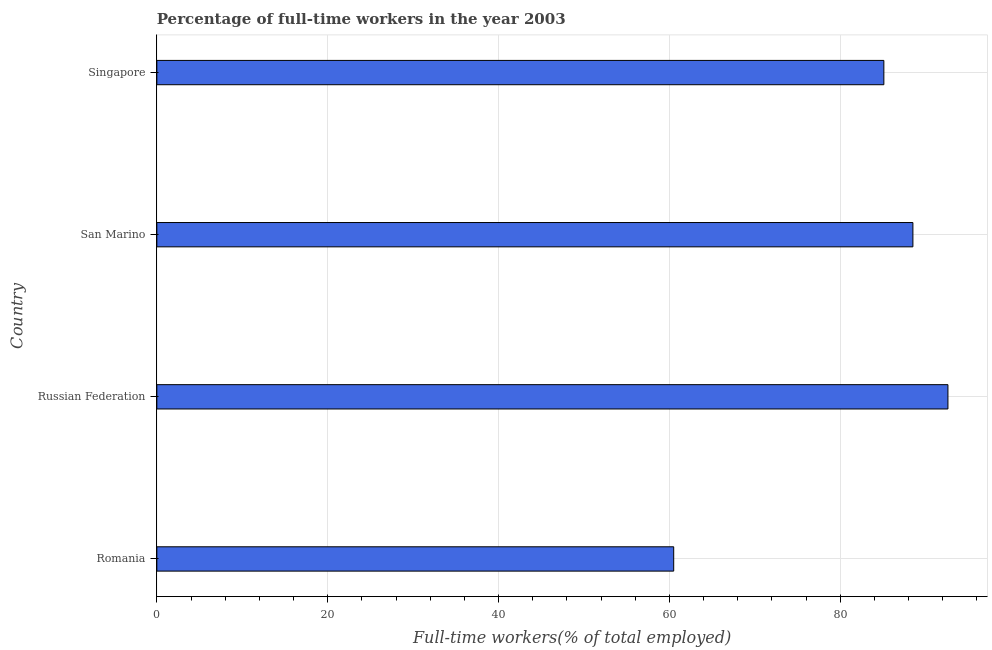Does the graph contain any zero values?
Ensure brevity in your answer.  No. What is the title of the graph?
Provide a short and direct response. Percentage of full-time workers in the year 2003. What is the label or title of the X-axis?
Your response must be concise. Full-time workers(% of total employed). What is the label or title of the Y-axis?
Offer a terse response. Country. What is the percentage of full-time workers in Singapore?
Provide a succinct answer. 85.1. Across all countries, what is the maximum percentage of full-time workers?
Keep it short and to the point. 92.6. Across all countries, what is the minimum percentage of full-time workers?
Give a very brief answer. 60.5. In which country was the percentage of full-time workers maximum?
Offer a very short reply. Russian Federation. In which country was the percentage of full-time workers minimum?
Provide a succinct answer. Romania. What is the sum of the percentage of full-time workers?
Keep it short and to the point. 326.7. What is the difference between the percentage of full-time workers in Romania and San Marino?
Provide a succinct answer. -28. What is the average percentage of full-time workers per country?
Keep it short and to the point. 81.67. What is the median percentage of full-time workers?
Provide a short and direct response. 86.8. In how many countries, is the percentage of full-time workers greater than 4 %?
Your answer should be compact. 4. What is the ratio of the percentage of full-time workers in Russian Federation to that in San Marino?
Provide a succinct answer. 1.05. Is the difference between the percentage of full-time workers in Russian Federation and San Marino greater than the difference between any two countries?
Offer a terse response. No. What is the difference between the highest and the second highest percentage of full-time workers?
Your answer should be very brief. 4.1. What is the difference between the highest and the lowest percentage of full-time workers?
Provide a short and direct response. 32.1. How many bars are there?
Your response must be concise. 4. What is the difference between two consecutive major ticks on the X-axis?
Provide a succinct answer. 20. Are the values on the major ticks of X-axis written in scientific E-notation?
Provide a succinct answer. No. What is the Full-time workers(% of total employed) in Romania?
Your response must be concise. 60.5. What is the Full-time workers(% of total employed) in Russian Federation?
Your answer should be very brief. 92.6. What is the Full-time workers(% of total employed) of San Marino?
Offer a terse response. 88.5. What is the Full-time workers(% of total employed) of Singapore?
Your response must be concise. 85.1. What is the difference between the Full-time workers(% of total employed) in Romania and Russian Federation?
Provide a short and direct response. -32.1. What is the difference between the Full-time workers(% of total employed) in Romania and San Marino?
Ensure brevity in your answer.  -28. What is the difference between the Full-time workers(% of total employed) in Romania and Singapore?
Your answer should be compact. -24.6. What is the difference between the Full-time workers(% of total employed) in Russian Federation and Singapore?
Your answer should be compact. 7.5. What is the ratio of the Full-time workers(% of total employed) in Romania to that in Russian Federation?
Provide a short and direct response. 0.65. What is the ratio of the Full-time workers(% of total employed) in Romania to that in San Marino?
Your response must be concise. 0.68. What is the ratio of the Full-time workers(% of total employed) in Romania to that in Singapore?
Keep it short and to the point. 0.71. What is the ratio of the Full-time workers(% of total employed) in Russian Federation to that in San Marino?
Make the answer very short. 1.05. What is the ratio of the Full-time workers(% of total employed) in Russian Federation to that in Singapore?
Keep it short and to the point. 1.09. What is the ratio of the Full-time workers(% of total employed) in San Marino to that in Singapore?
Give a very brief answer. 1.04. 